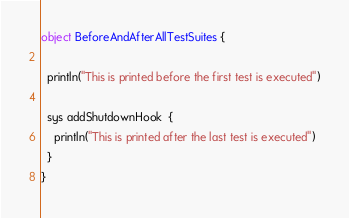Convert code to text. <code><loc_0><loc_0><loc_500><loc_500><_Scala_>object BeforeAndAfterAllTestSuites {

  println("This is printed before the first test is executed")

  sys addShutdownHook  {
    println("This is printed after the last test is executed")
  }
}
</code> 